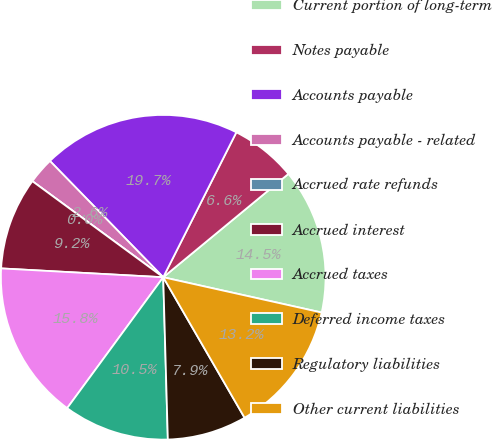Convert chart to OTSL. <chart><loc_0><loc_0><loc_500><loc_500><pie_chart><fcel>Current portion of long-term<fcel>Notes payable<fcel>Accounts payable<fcel>Accounts payable - related<fcel>Accrued rate refunds<fcel>Accrued interest<fcel>Accrued taxes<fcel>Deferred income taxes<fcel>Regulatory liabilities<fcel>Other current liabilities<nl><fcel>14.47%<fcel>6.58%<fcel>19.73%<fcel>2.63%<fcel>0.0%<fcel>9.21%<fcel>15.79%<fcel>10.53%<fcel>7.9%<fcel>13.16%<nl></chart> 